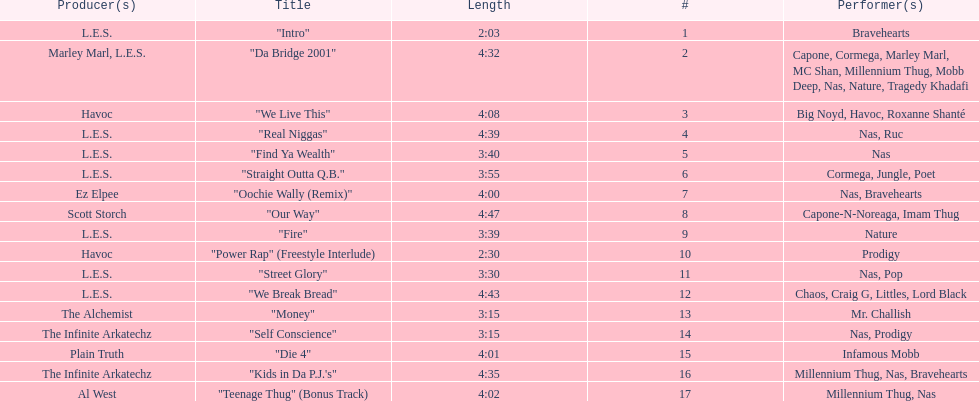Give me the full table as a dictionary. {'header': ['Producer(s)', 'Title', 'Length', '#', 'Performer(s)'], 'rows': [['L.E.S.', '"Intro"', '2:03', '1', 'Bravehearts'], ['Marley Marl, L.E.S.', '"Da Bridge 2001"', '4:32', '2', 'Capone, Cormega, Marley Marl, MC Shan, Millennium Thug, Mobb Deep, Nas, Nature, Tragedy Khadafi'], ['Havoc', '"We Live This"', '4:08', '3', 'Big Noyd, Havoc, Roxanne Shanté'], ['L.E.S.', '"Real Niggas"', '4:39', '4', 'Nas, Ruc'], ['L.E.S.', '"Find Ya Wealth"', '3:40', '5', 'Nas'], ['L.E.S.', '"Straight Outta Q.B."', '3:55', '6', 'Cormega, Jungle, Poet'], ['Ez Elpee', '"Oochie Wally (Remix)"', '4:00', '7', 'Nas, Bravehearts'], ['Scott Storch', '"Our Way"', '4:47', '8', 'Capone-N-Noreaga, Imam Thug'], ['L.E.S.', '"Fire"', '3:39', '9', 'Nature'], ['Havoc', '"Power Rap" (Freestyle Interlude)', '2:30', '10', 'Prodigy'], ['L.E.S.', '"Street Glory"', '3:30', '11', 'Nas, Pop'], ['L.E.S.', '"We Break Bread"', '4:43', '12', 'Chaos, Craig G, Littles, Lord Black'], ['The Alchemist', '"Money"', '3:15', '13', 'Mr. Challish'], ['The Infinite Arkatechz', '"Self Conscience"', '3:15', '14', 'Nas, Prodigy'], ['Plain Truth', '"Die 4"', '4:01', '15', 'Infamous Mobb'], ['The Infinite Arkatechz', '"Kids in Da P.J.\'s"', '4:35', '16', 'Millennium Thug, Nas, Bravehearts'], ['Al West', '"Teenage Thug" (Bonus Track)', '4:02', '17', 'Millennium Thug, Nas']]} After street glory, what song is listed? "We Break Bread". 